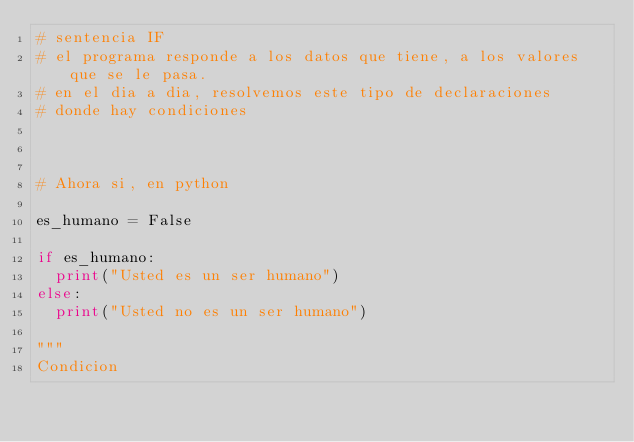<code> <loc_0><loc_0><loc_500><loc_500><_Python_># sentencia IF
# el programa responde a los datos que tiene, a los valores que se le pasa.
# en el dia a dia, resolvemos este tipo de declaraciones
# donde hay condiciones



# Ahora si, en python

es_humano = False

if es_humano:
  print("Usted es un ser humano")
else:
  print("Usted no es un ser humano")

"""
Condicion</code> 